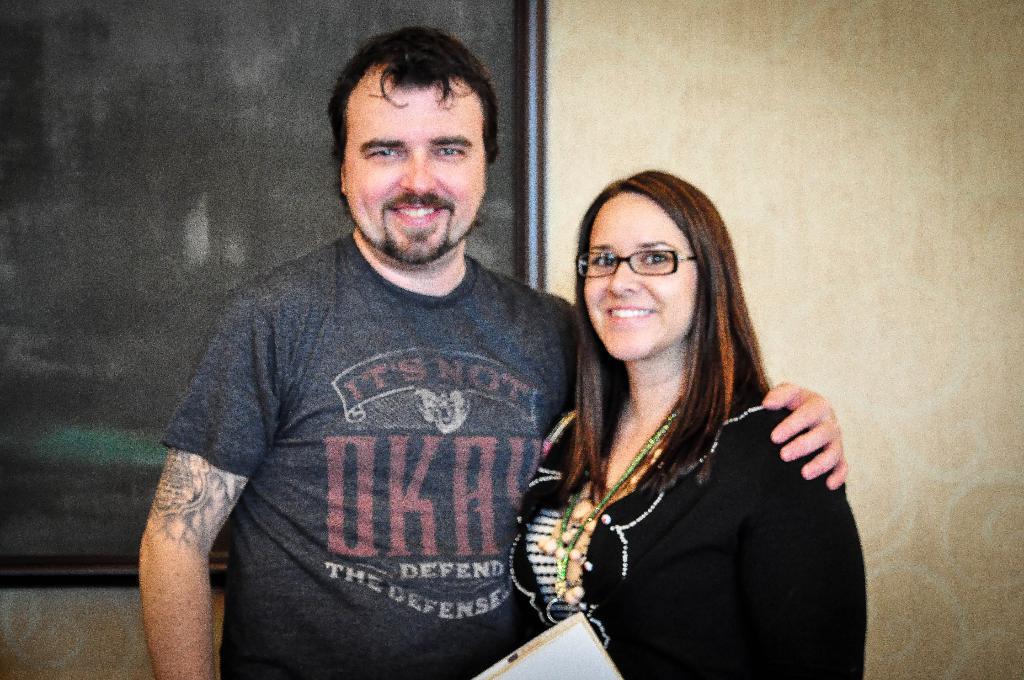In one or two sentences, can you explain what this image depicts? In this image, we can see people standing and smiling and one of them is wearing glasses and holding an object. In the background, there is a board and a wall. 